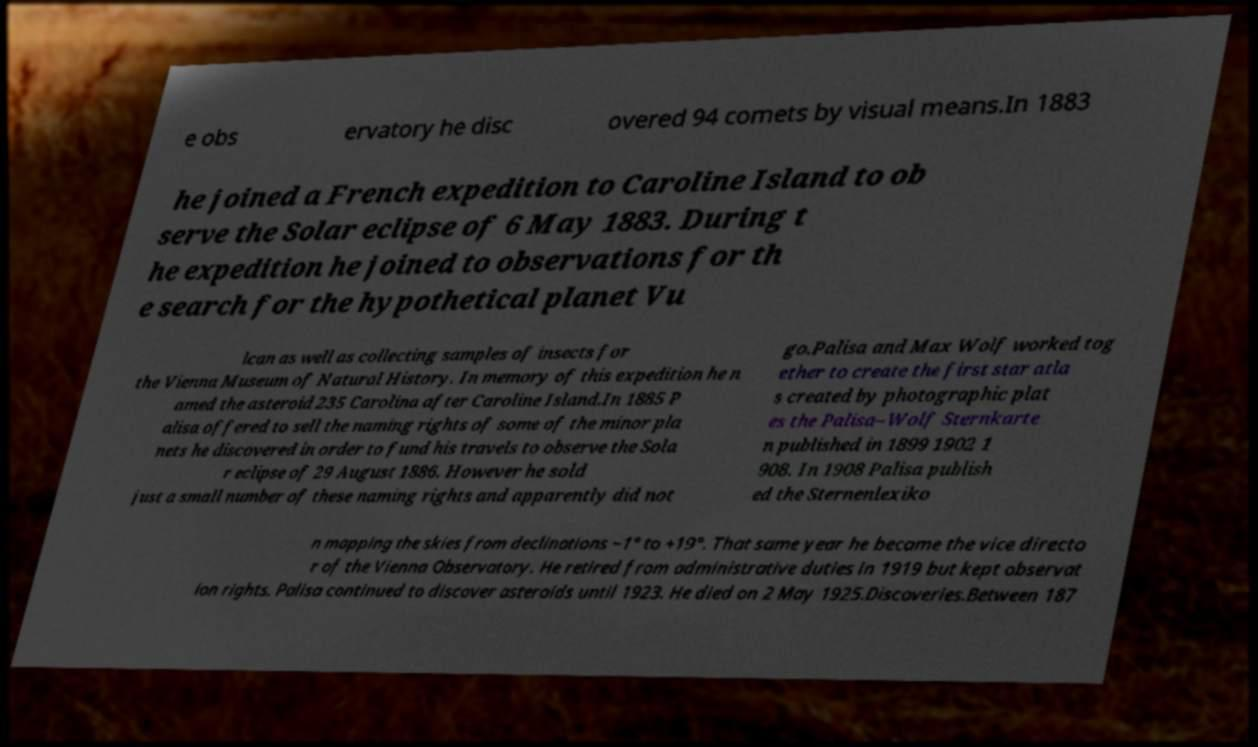Could you extract and type out the text from this image? e obs ervatory he disc overed 94 comets by visual means.In 1883 he joined a French expedition to Caroline Island to ob serve the Solar eclipse of 6 May 1883. During t he expedition he joined to observations for th e search for the hypothetical planet Vu lcan as well as collecting samples of insects for the Vienna Museum of Natural History. In memory of this expedition he n amed the asteroid 235 Carolina after Caroline Island.In 1885 P alisa offered to sell the naming rights of some of the minor pla nets he discovered in order to fund his travels to observe the Sola r eclipse of 29 August 1886. However he sold just a small number of these naming rights and apparently did not go.Palisa and Max Wolf worked tog ether to create the first star atla s created by photographic plat es the Palisa–Wolf Sternkarte n published in 1899 1902 1 908. In 1908 Palisa publish ed the Sternenlexiko n mapping the skies from declinations −1° to +19°. That same year he became the vice directo r of the Vienna Observatory. He retired from administrative duties in 1919 but kept observat ion rights. Palisa continued to discover asteroids until 1923. He died on 2 May 1925.Discoveries.Between 187 